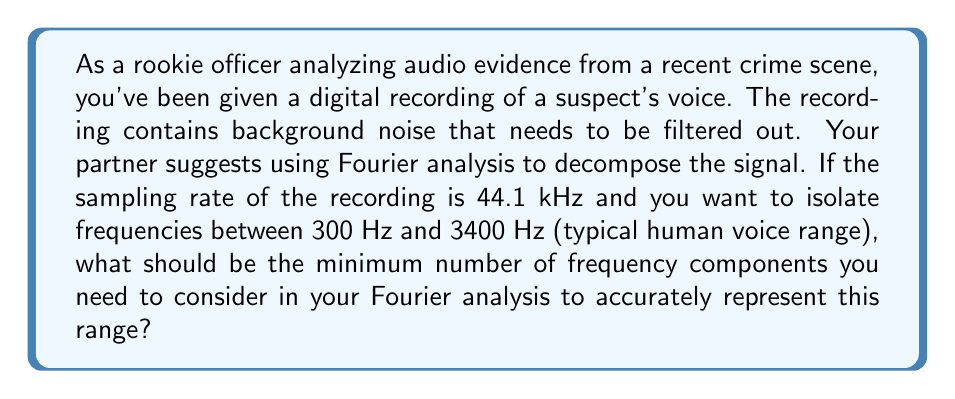What is the answer to this math problem? Let's approach this step-by-step:

1) The Nyquist-Shannon sampling theorem states that to accurately represent a signal, we need to sample at least twice the highest frequency in the signal.

2) In this case, the sampling rate is 44.1 kHz = 44100 Hz.

3) The highest frequency we're interested in is 3400 Hz.

4) The number of frequency components (N) in a discrete Fourier transform is related to the sampling rate (fs) and the frequency resolution (Δf) by the equation:

   $$ N = \frac{f_s}{\Delta f} $$

5) The frequency resolution needed to distinguish between 300 Hz and 3400 Hz is:

   $$ \Delta f = 3400 \text{ Hz} - 300 \text{ Hz} = 3100 \text{ Hz} $$

6) Substituting into the equation:

   $$ N = \frac{44100 \text{ Hz}}{3100 \text{ Hz}} \approx 14.23 $$

7) Since we need a whole number of components, we round up to the nearest integer.

Therefore, the minimum number of frequency components needed is 15.
Answer: 15 components 